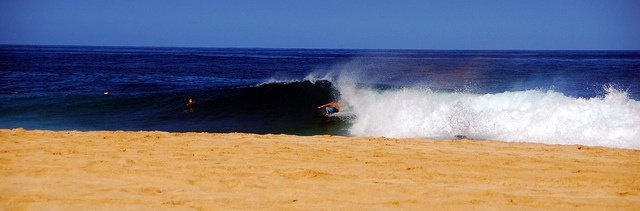Describe the objects in this image and their specific colors. I can see people in blue, black, maroon, red, and brown tones, surfboard in blue, darkgray, gray, and black tones, and people in blue, black, maroon, and brown tones in this image. 